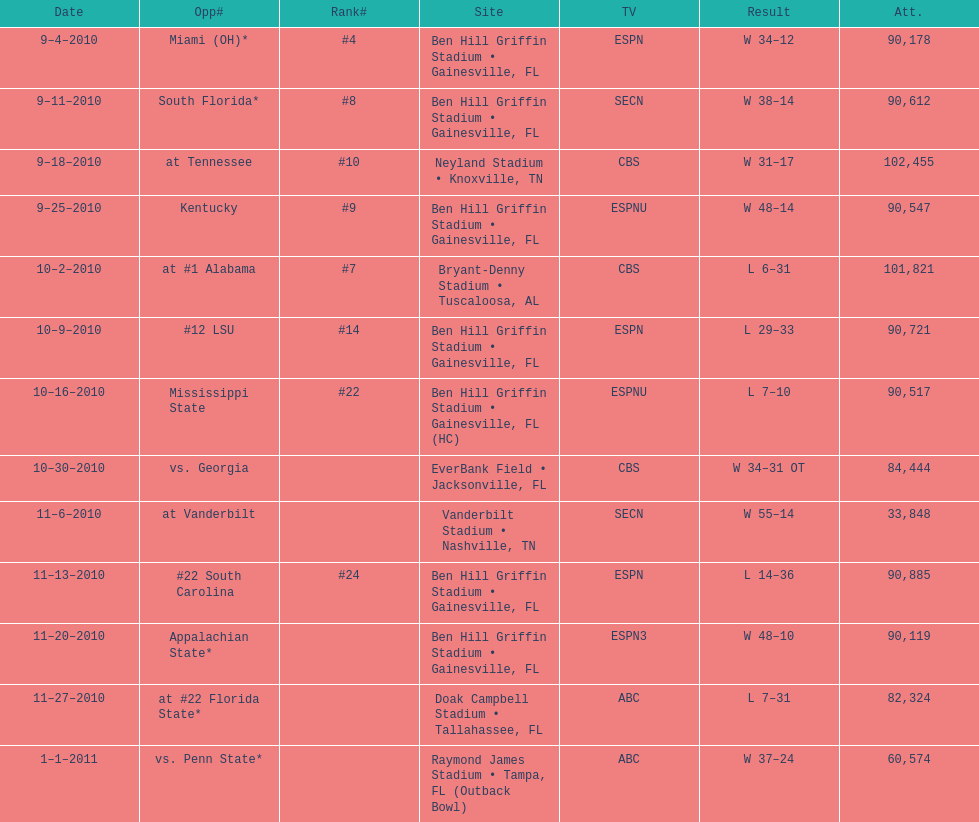What is the number of games played in teh 2010-2011 season 13. 